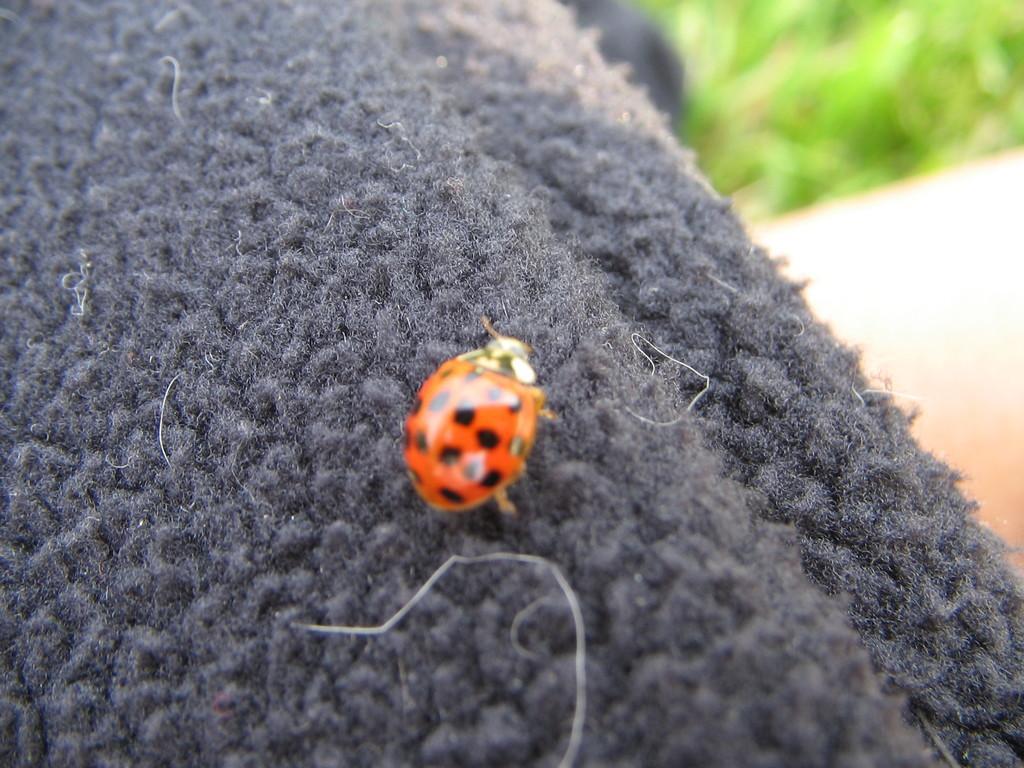Describe this image in one or two sentences. In this image we can see a bug on a woolen cloth. On the backside we can see some grass. 